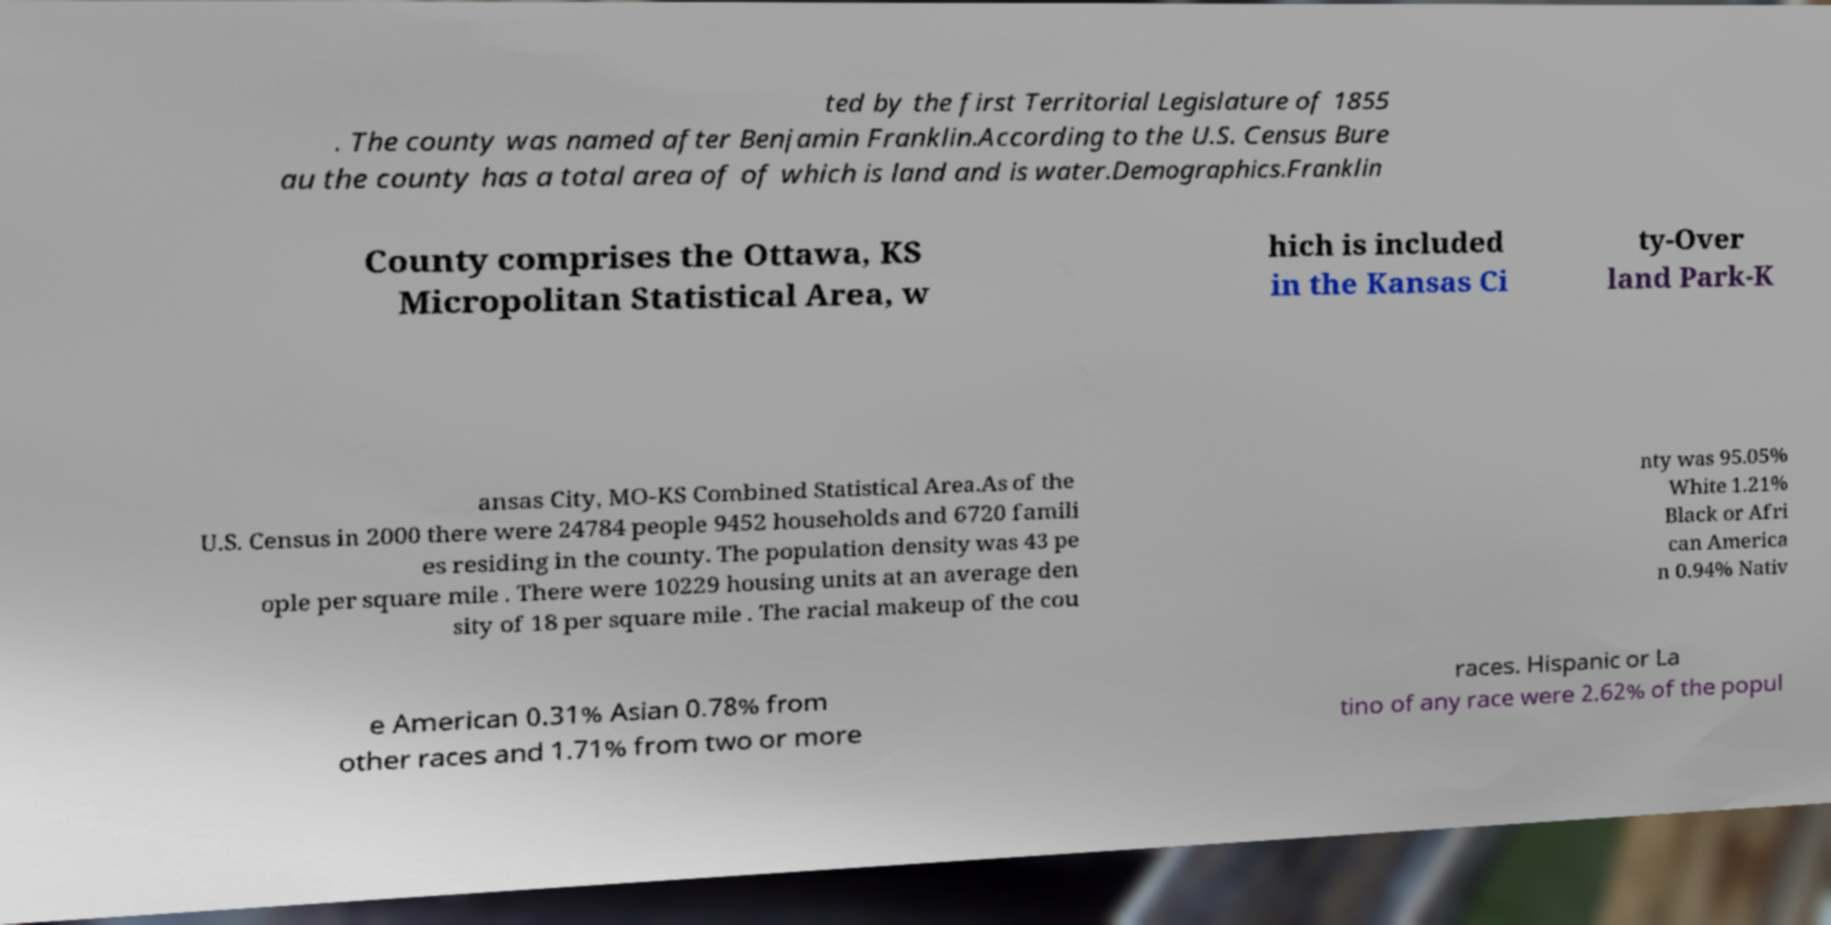Please read and relay the text visible in this image. What does it say? ted by the first Territorial Legislature of 1855 . The county was named after Benjamin Franklin.According to the U.S. Census Bure au the county has a total area of of which is land and is water.Demographics.Franklin County comprises the Ottawa, KS Micropolitan Statistical Area, w hich is included in the Kansas Ci ty-Over land Park-K ansas City, MO-KS Combined Statistical Area.As of the U.S. Census in 2000 there were 24784 people 9452 households and 6720 famili es residing in the county. The population density was 43 pe ople per square mile . There were 10229 housing units at an average den sity of 18 per square mile . The racial makeup of the cou nty was 95.05% White 1.21% Black or Afri can America n 0.94% Nativ e American 0.31% Asian 0.78% from other races and 1.71% from two or more races. Hispanic or La tino of any race were 2.62% of the popul 